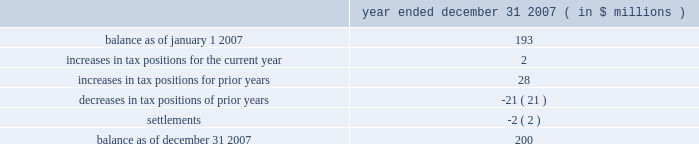Determined that it will primarily be subject to the ietu in future periods , and as such it has recorded tax expense of approximately $ 20 million in 2007 for the deferred tax effects of the new ietu system .
As of december 31 , 2007 , the company had us federal net operating loss carryforwards of approximately $ 206 million which will begin to expire in 2023 .
Of this amount , $ 47 million relates to the pre-acquisition period and is subject to limitation .
The remaining $ 159 million is subject to limitation as a result of the change in stock ownership in may 2006 .
This limitation is not expected to have a material impact on utilization of the net operating loss carryforwards .
The company also had foreign net operating loss carryforwards as of december 31 , 2007 of approximately $ 564 million for canada , germany , mexico and other foreign jurisdictions with various expiration dates .
Net operating losses in canada have various carryforward periods and began expiring in 2007 .
Net operating losses in germany have no expiration date .
Net operating losses in mexico have a ten year carryforward period and begin to expire in 2009 .
However , these losses are not available for use under the new ietu tax regulations in mexico .
As the ietu is the primary system upon which the company will be subject to tax in future periods , no deferred tax asset has been reflected in the balance sheet as of december 31 , 2007 for these income tax loss carryforwards .
The company adopted the provisions of fin 48 effective january 1 , 2007 .
Fin 48 clarifies the accounting for income taxes by prescribing a minimum recognition threshold a tax benefit is required to meet before being recognized in the financial statements .
Fin 48 also provides guidance on derecognition , measurement , classification , interest and penalties , accounting in interim periods , disclosure and transition .
As a result of the implementation of fin 48 , the company increased retained earnings by $ 14 million and decreased goodwill by $ 2 million .
In addition , certain tax liabilities for unrecognized tax benefits , as well as related potential penalties and interest , were reclassified from current liabilities to long-term liabilities .
Liabilities for unrecognized tax benefits as of december 31 , 2007 relate to various us and foreign jurisdictions .
A reconciliation of the beginning and ending amount of unrecognized tax benefits is as follows : year ended december 31 , 2007 ( in $ millions ) .
Included in the unrecognized tax benefits of $ 200 million as of december 31 , 2007 is $ 56 million of tax benefits that , if recognized , would reduce the company 2019s effective tax rate .
The company recognizes interest and penalties related to unrecognized tax benefits in the provision for income taxes .
As of december 31 , 2007 , the company has recorded a liability of approximately $ 36 million for interest and penalties .
This amount includes an increase of approximately $ 13 million for the year ended december 31 , 2007 .
The company operates in the united states ( including multiple state jurisdictions ) , germany and approximately 40 other foreign jurisdictions including canada , china , france , mexico and singapore .
Examinations are ongoing in a number of those jurisdictions including , most significantly , in germany for the years 2001 to 2004 .
During the quarter ended march 31 , 2007 , the company received final assessments in germany for the prior examination period , 1997 to 2000 .
The effective settlement of those examinations resulted in a reduction to goodwill of approximately $ 42 million with a net expected cash outlay of $ 29 million .
The company 2019s celanese corporation and subsidiaries notes to consolidated financial statements 2014 ( continued ) %%transmsg*** transmitting job : y48011 pcn : 122000000 ***%%pcmsg|f-49 |00023|yes|no|02/26/2008 22:07|0|0|page is valid , no graphics -- color : d| .
What is the percentage change in the balance of unrecognized tax benefits during 2007? 
Computations: ((200 - 193) / 193)
Answer: 0.03627. 